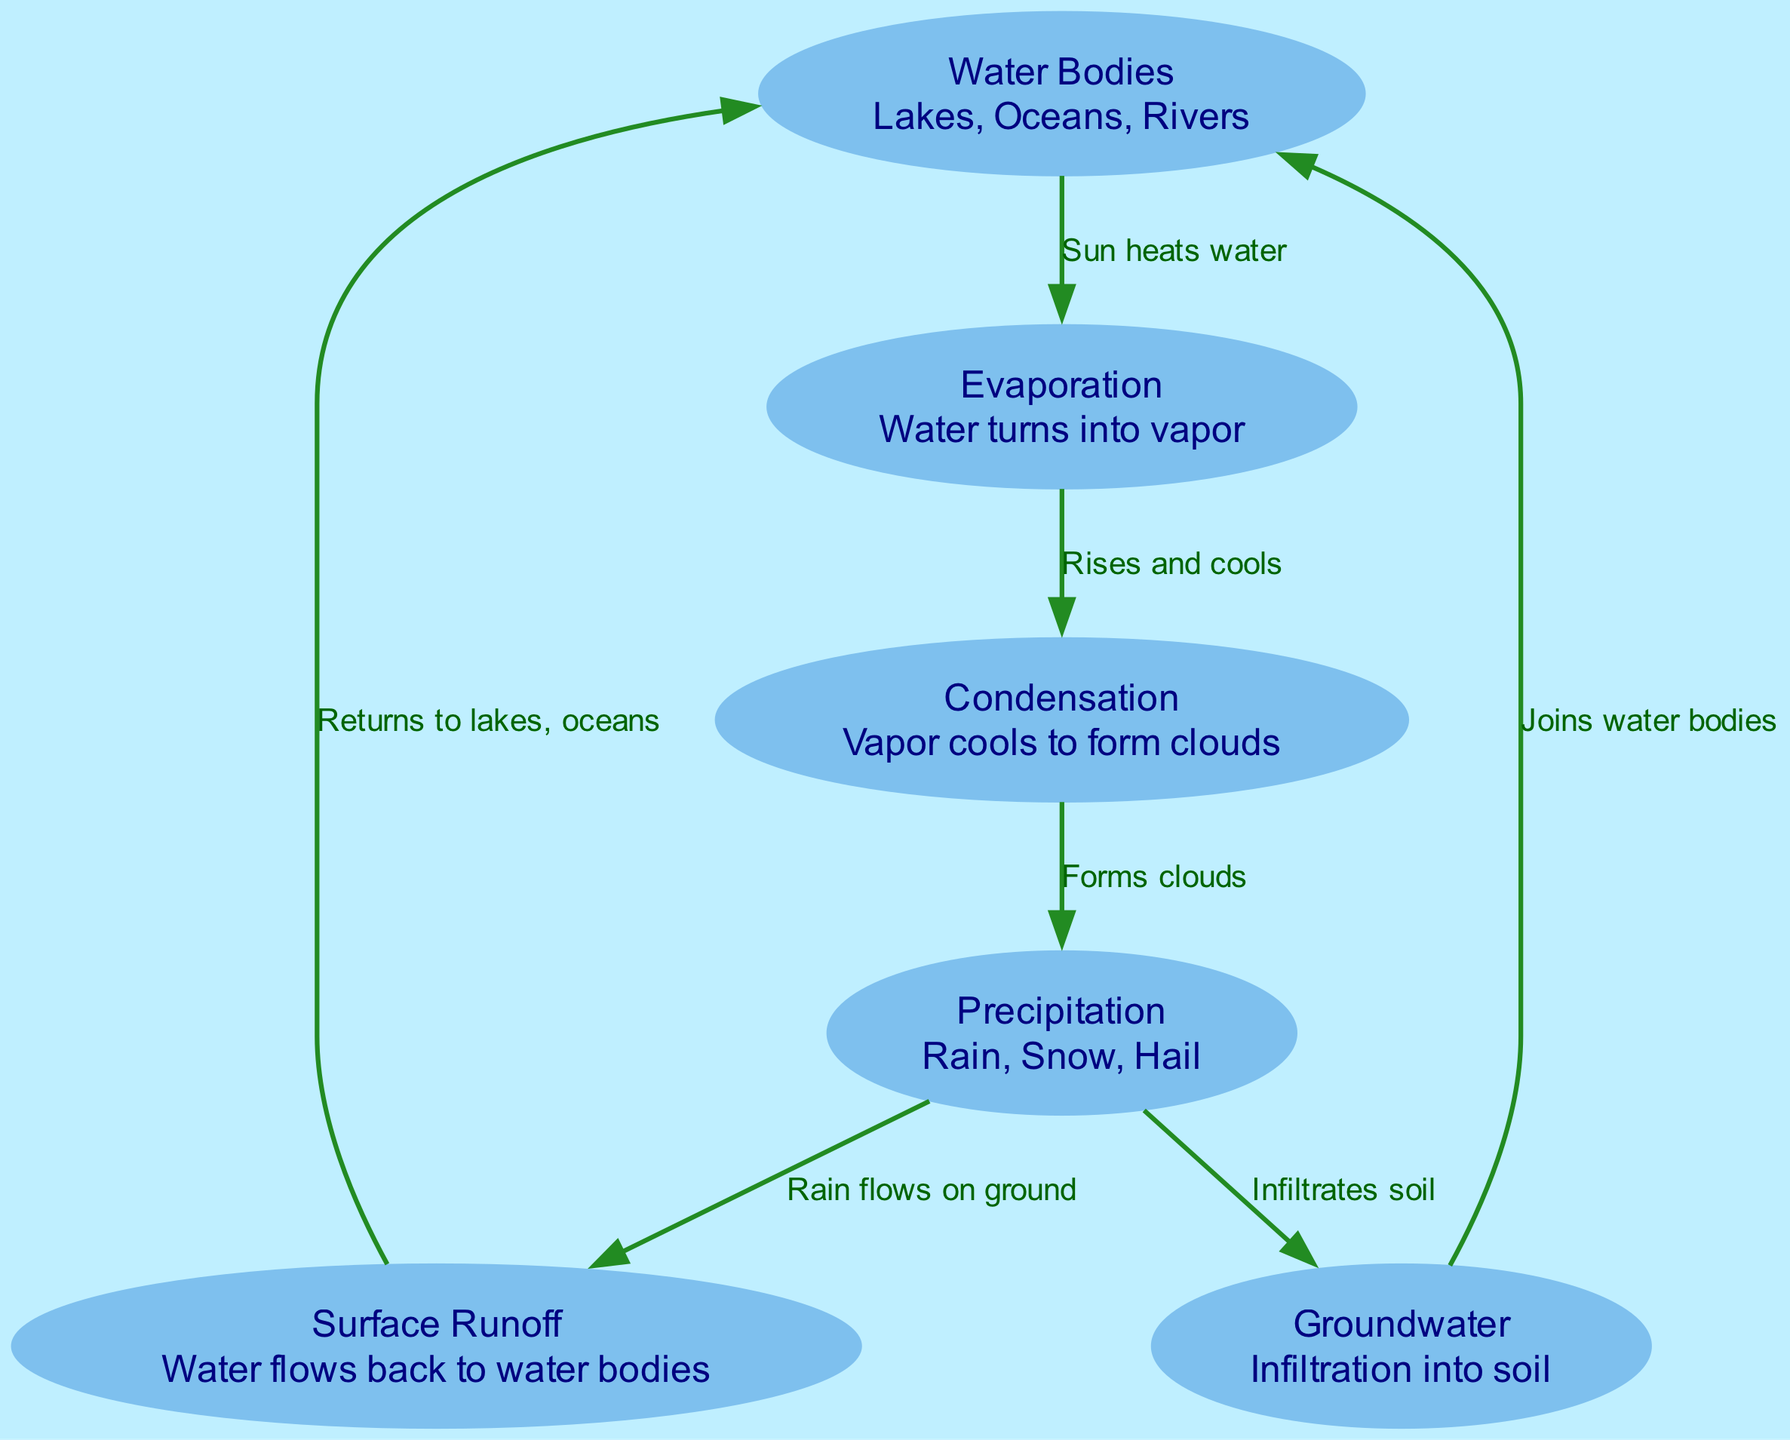What are the stages included in the water cycle diagram? The diagram includes six main stages represented by nodes: Water Bodies, Evaporation, Condensation, Precipitation, Surface Runoff, and Groundwater. These are listed in the node descriptions.
Answer: Evaporation, Condensation, Precipitation, Surface Runoff, Groundwater What is the relationship between evaporation and condensation? The diagram shows that evaporation occurs first when water vapor rises and cools down to form condensation, which is represented by an arrow from evaporation to condensation.
Answer: Rises and cools How many nodes are depicted in the diagram? The diagram contains six nodes that represent different stages in the water cycle, as labeled in the node list.
Answer: 6 What happens during the precipitation stage? According to the diagram, precipitation includes forms such as rain, snow, and hail, which are depicted in the precipitation node description.
Answer: Rain, Snow, Hail What node represents the return of water to lakes and oceans? The edge leading from the Surface Runoff node back to the Water Bodies node indicates that surface runoff returns water to large bodies of water.
Answer: Water Bodies What process occurs after precipitation infiltrates the soil? The diagram indicates that after precipitation infiltrates the soil, it becomes groundwater, which is illustrated by an arrow moving from precipitation to groundwater.
Answer: Groundwater Which node involves the process of solar heating? The edge connecting the Water Bodies node to the Evaporation node indicates that this process involves solar heating of water.
Answer: Evaporation Describe how groundwater reenters the water bodies. The diagram shows an edge from the Groundwater node that leads back to the Water Bodies node, which indicates that groundwater joins the water bodies as part of the cycle.
Answer: Joins water bodies 